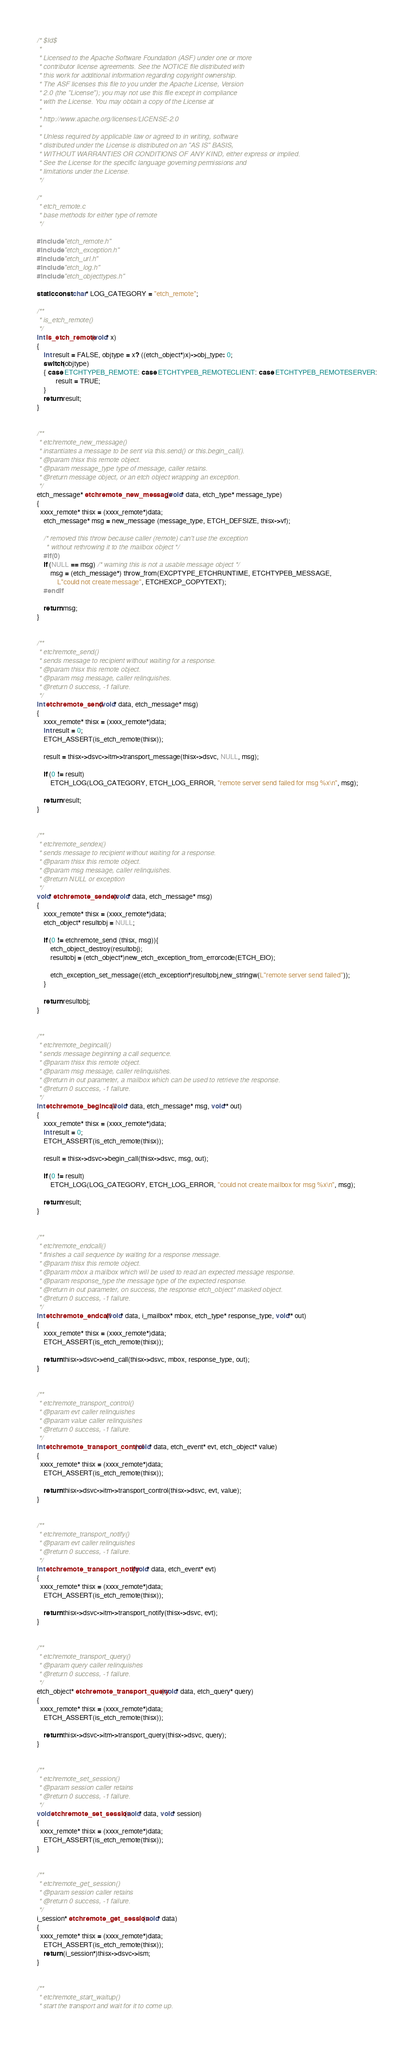Convert code to text. <code><loc_0><loc_0><loc_500><loc_500><_C_>/* $Id$ 
 * 
 * Licensed to the Apache Software Foundation (ASF) under one or more 
 * contributor license agreements. See the NOTICE file distributed with  
 * this work for additional information regarding copyright ownership. 
 * The ASF licenses this file to you under the Apache License, Version  
 * 2.0 (the "License"); you may not use this file except in compliance  
 * with the License. You may obtain a copy of the License at 
 * 
 * http://www.apache.org/licenses/LICENSE-2.0 
 * 
 * Unless required by applicable law or agreed to in writing, software 
 * distributed under the License is distributed on an "AS IS" BASIS, 
 * WITHOUT WARRANTIES OR CONDITIONS OF ANY KIND, either express or implied.
 * See the License for the specific language governing permissions and 
 * limitations under the License. 
 */ 

/*
 * etch_remote.c 
 * base methods for either type of remote
 */

#include "etch_remote.h"
#include "etch_exception.h"
#include "etch_url.h"
#include "etch_log.h"
#include "etch_objecttypes.h"

static const char* LOG_CATEGORY = "etch_remote";

/**
 * is_etch_remote()
 */
int is_etch_remote(void* x)
{
    int result = FALSE, objtype = x? ((etch_object*)x)->obj_type: 0;
    switch(objtype)
    { case ETCHTYPEB_REMOTE: case ETCHTYPEB_REMOTECLIENT: case ETCHTYPEB_REMOTESERVER:
           result = TRUE;
    }
    return result;
}            


/**
 * etchremote_new_message()
 * instantiates a message to be sent via this.send() or this.begin_call().
 * @param thisx this remote object.
 * @param message_type type of message, caller retains.
 * @return message object, or an etch object wrapping an exception.
 */
etch_message* etchremote_new_message (void* data, etch_type* message_type)
{
  xxxx_remote* thisx = (xxxx_remote*)data;
    etch_message* msg = new_message (message_type, ETCH_DEFSIZE, thisx->vf);

    /* removed this throw because caller (remote) can't use the exception
     * without rethrowing it to the mailbox object */
    #if(0)
    if (NULL == msg) /* warning this is not a usable message object */
        msg = (etch_message*) throw_from(EXCPTYPE_ETCHRUNTIME, ETCHTYPEB_MESSAGE, 
            L"could not create message", ETCHEXCP_COPYTEXT);
    #endif

    return msg;
}


/**
 * etchremote_send()
 * sends message to recipient without waiting for a response.
 * @param thisx this remote object.
 * @param msg message, caller relinquishes.
 * @return 0 success, -1 failure.
 */
int etchremote_send (void* data, etch_message* msg)
{
    xxxx_remote* thisx = (xxxx_remote*)data;
    int result = 0;
    ETCH_ASSERT(is_etch_remote(thisx));
    
    result = thisx->dsvc->itm->transport_message(thisx->dsvc, NULL, msg);

    if (0 != result)
        ETCH_LOG(LOG_CATEGORY, ETCH_LOG_ERROR, "remote server send failed for msg %x\n", msg);

    return result;
}


/**
 * etchremote_sendex()
 * sends message to recipient without waiting for a response.
 * @param thisx this remote object.
 * @param msg message, caller relinquishes.
 * @return NULL or exception
 */
void* etchremote_sendex (void* data, etch_message* msg)
{
    xxxx_remote* thisx = (xxxx_remote*)data;
    etch_object* resultobj = NULL;

    if (0 != etchremote_send (thisx, msg)){
        etch_object_destroy(resultobj);
        resultobj = (etch_object*)new_etch_exception_from_errorcode(ETCH_EIO);

        etch_exception_set_message((etch_exception*)resultobj,new_stringw(L"remote server send failed"));
    }
    
    return resultobj;
}


/**
 * etchremote_begincall()
 * sends message beginning a call sequence.
 * @param thisx this remote object.
 * @param msg message, caller relinquishes.
 * @return in out parameter, a mailbox which can be used to retrieve the response.
 * @return 0 success, -1 failure.
 */
int etchremote_begincall (void* data, etch_message* msg, void** out)
{
    xxxx_remote* thisx = (xxxx_remote*)data;
    int result = 0;
    ETCH_ASSERT(is_etch_remote(thisx));

    result = thisx->dsvc->begin_call(thisx->dsvc, msg, out);

    if (0 != result) 
        ETCH_LOG(LOG_CATEGORY, ETCH_LOG_ERROR, "could not create mailbox for msg %x\n", msg);
         
    return result;
}


/**
 * etchremote_endcall()
 * finishes a call sequence by waiting for a response message.
 * @param thisx this remote object.
 * @param mbox a mailbox which will be used to read an expected message response.
 * @param response_type the message type of the expected response.
 * @return in out parameter, on success, the response etch_object* masked object.
 * @return 0 success, -1 failure.
 */
int etchremote_endcall (void* data, i_mailbox* mbox, etch_type* response_type, void** out)
{   
    xxxx_remote* thisx = (xxxx_remote*)data;
    ETCH_ASSERT(is_etch_remote(thisx));

    return thisx->dsvc->end_call(thisx->dsvc, mbox, response_type, out);
}


/**
 * etchremote_transport_control()
 * @param evt caller relinquishes
 * @param value caller relinquishes
 * @return 0 success, -1 failure.
 */
int etchremote_transport_control (void* data, etch_event* evt, etch_object* value)
{
  xxxx_remote* thisx = (xxxx_remote*)data;
    ETCH_ASSERT(is_etch_remote(thisx));

    return thisx->dsvc->itm->transport_control(thisx->dsvc, evt, value);
}


/**
 * etchremote_transport_notify()
 * @param evt caller relinquishes
 * @return 0 success, -1 failure.
 */
int etchremote_transport_notify  (void* data, etch_event* evt)
{
  xxxx_remote* thisx = (xxxx_remote*)data;
    ETCH_ASSERT(is_etch_remote(thisx));
    
    return thisx->dsvc->itm->transport_notify(thisx->dsvc, evt);
}


/**
 * etchremote_transport_query()
 * @param query caller relinquishes
 * @return 0 success, -1 failure.
 */
etch_object* etchremote_transport_query (void* data, etch_query* query) 
{
  xxxx_remote* thisx = (xxxx_remote*)data;
    ETCH_ASSERT(is_etch_remote(thisx));
    
    return thisx->dsvc->itm->transport_query(thisx->dsvc, query);
}


/**
 * etchremote_set_session()
 * @param session caller retains  
 * @return 0 success, -1 failure.
 */
void etchremote_set_session (void* data, void* session) 
{
  xxxx_remote* thisx = (xxxx_remote*)data;
    ETCH_ASSERT(is_etch_remote(thisx)); 
}


/**
 * etchremote_get_session()
 * @param session caller retains  
 * @return 0 success, -1 failure.
 */
i_session* etchremote_get_session (void* data)
{           
  xxxx_remote* thisx = (xxxx_remote*)data;
    ETCH_ASSERT(is_etch_remote(thisx)); 
    return (i_session*)thisx->dsvc->ism;
}


/**
 * etchremote_start_waitup()
 * start the transport and wait for it to come up.</code> 